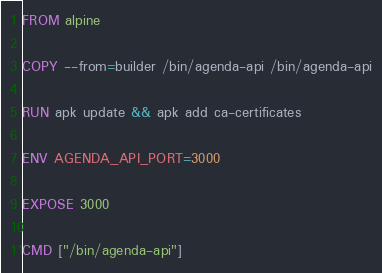<code> <loc_0><loc_0><loc_500><loc_500><_Dockerfile_>
FROM alpine

COPY --from=builder /bin/agenda-api /bin/agenda-api

RUN apk update && apk add ca-certificates

ENV AGENDA_API_PORT=3000

EXPOSE 3000

CMD ["/bin/agenda-api"]
</code> 